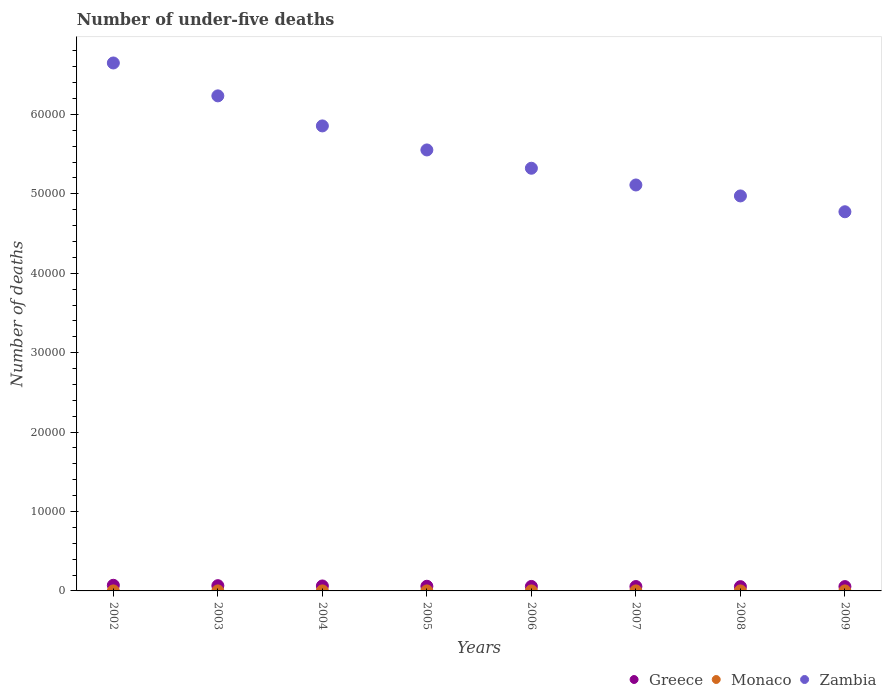How many different coloured dotlines are there?
Your answer should be very brief. 3. What is the number of under-five deaths in Greece in 2007?
Make the answer very short. 552. Across all years, what is the maximum number of under-five deaths in Zambia?
Your answer should be very brief. 6.65e+04. Across all years, what is the minimum number of under-five deaths in Zambia?
Provide a succinct answer. 4.77e+04. In which year was the number of under-five deaths in Monaco maximum?
Your response must be concise. 2003. What is the total number of under-five deaths in Zambia in the graph?
Your answer should be compact. 4.45e+05. What is the difference between the number of under-five deaths in Greece in 2003 and that in 2007?
Your answer should be very brief. 109. What is the difference between the number of under-five deaths in Monaco in 2006 and the number of under-five deaths in Zambia in 2005?
Provide a short and direct response. -5.55e+04. What is the average number of under-five deaths in Greece per year?
Your answer should be very brief. 597.75. In the year 2005, what is the difference between the number of under-five deaths in Zambia and number of under-five deaths in Monaco?
Provide a succinct answer. 5.55e+04. In how many years, is the number of under-five deaths in Monaco greater than 36000?
Provide a succinct answer. 0. What is the ratio of the number of under-five deaths in Zambia in 2006 to that in 2008?
Your answer should be compact. 1.07. Is the number of under-five deaths in Zambia in 2004 less than that in 2009?
Ensure brevity in your answer.  No. Is it the case that in every year, the sum of the number of under-five deaths in Monaco and number of under-five deaths in Zambia  is greater than the number of under-five deaths in Greece?
Offer a terse response. Yes. Does the number of under-five deaths in Monaco monotonically increase over the years?
Your answer should be very brief. No. Is the number of under-five deaths in Zambia strictly greater than the number of under-five deaths in Greece over the years?
Ensure brevity in your answer.  Yes. Is the number of under-five deaths in Monaco strictly less than the number of under-five deaths in Zambia over the years?
Make the answer very short. Yes. How many years are there in the graph?
Your answer should be very brief. 8. Are the values on the major ticks of Y-axis written in scientific E-notation?
Ensure brevity in your answer.  No. Does the graph contain any zero values?
Offer a very short reply. No. How many legend labels are there?
Ensure brevity in your answer.  3. How are the legend labels stacked?
Make the answer very short. Horizontal. What is the title of the graph?
Keep it short and to the point. Number of under-five deaths. Does "Brunei Darussalam" appear as one of the legend labels in the graph?
Offer a very short reply. No. What is the label or title of the X-axis?
Your answer should be very brief. Years. What is the label or title of the Y-axis?
Give a very brief answer. Number of deaths. What is the Number of deaths in Greece in 2002?
Your response must be concise. 710. What is the Number of deaths of Zambia in 2002?
Keep it short and to the point. 6.65e+04. What is the Number of deaths of Greece in 2003?
Your response must be concise. 661. What is the Number of deaths of Zambia in 2003?
Offer a very short reply. 6.23e+04. What is the Number of deaths of Greece in 2004?
Your response must be concise. 624. What is the Number of deaths in Zambia in 2004?
Your answer should be compact. 5.86e+04. What is the Number of deaths of Greece in 2005?
Ensure brevity in your answer.  588. What is the Number of deaths of Zambia in 2005?
Provide a short and direct response. 5.55e+04. What is the Number of deaths of Greece in 2006?
Give a very brief answer. 564. What is the Number of deaths in Monaco in 2006?
Your answer should be compact. 1. What is the Number of deaths in Zambia in 2006?
Provide a succinct answer. 5.32e+04. What is the Number of deaths in Greece in 2007?
Your answer should be very brief. 552. What is the Number of deaths in Zambia in 2007?
Your answer should be very brief. 5.11e+04. What is the Number of deaths of Greece in 2008?
Your answer should be very brief. 538. What is the Number of deaths of Monaco in 2008?
Offer a very short reply. 1. What is the Number of deaths of Zambia in 2008?
Give a very brief answer. 4.97e+04. What is the Number of deaths in Greece in 2009?
Your answer should be very brief. 545. What is the Number of deaths of Monaco in 2009?
Provide a short and direct response. 1. What is the Number of deaths in Zambia in 2009?
Keep it short and to the point. 4.77e+04. Across all years, what is the maximum Number of deaths of Greece?
Offer a terse response. 710. Across all years, what is the maximum Number of deaths of Zambia?
Give a very brief answer. 6.65e+04. Across all years, what is the minimum Number of deaths in Greece?
Offer a terse response. 538. Across all years, what is the minimum Number of deaths in Zambia?
Ensure brevity in your answer.  4.77e+04. What is the total Number of deaths in Greece in the graph?
Provide a succinct answer. 4782. What is the total Number of deaths of Zambia in the graph?
Your answer should be compact. 4.45e+05. What is the difference between the Number of deaths of Greece in 2002 and that in 2003?
Make the answer very short. 49. What is the difference between the Number of deaths of Monaco in 2002 and that in 2003?
Your response must be concise. -1. What is the difference between the Number of deaths in Zambia in 2002 and that in 2003?
Offer a terse response. 4142. What is the difference between the Number of deaths of Monaco in 2002 and that in 2004?
Keep it short and to the point. -1. What is the difference between the Number of deaths of Zambia in 2002 and that in 2004?
Your answer should be compact. 7925. What is the difference between the Number of deaths in Greece in 2002 and that in 2005?
Your answer should be very brief. 122. What is the difference between the Number of deaths of Monaco in 2002 and that in 2005?
Provide a succinct answer. 0. What is the difference between the Number of deaths of Zambia in 2002 and that in 2005?
Your answer should be compact. 1.10e+04. What is the difference between the Number of deaths in Greece in 2002 and that in 2006?
Your response must be concise. 146. What is the difference between the Number of deaths of Monaco in 2002 and that in 2006?
Offer a very short reply. 0. What is the difference between the Number of deaths in Zambia in 2002 and that in 2006?
Your response must be concise. 1.33e+04. What is the difference between the Number of deaths of Greece in 2002 and that in 2007?
Give a very brief answer. 158. What is the difference between the Number of deaths in Monaco in 2002 and that in 2007?
Your answer should be compact. 0. What is the difference between the Number of deaths of Zambia in 2002 and that in 2007?
Offer a very short reply. 1.54e+04. What is the difference between the Number of deaths of Greece in 2002 and that in 2008?
Keep it short and to the point. 172. What is the difference between the Number of deaths in Zambia in 2002 and that in 2008?
Your response must be concise. 1.67e+04. What is the difference between the Number of deaths in Greece in 2002 and that in 2009?
Ensure brevity in your answer.  165. What is the difference between the Number of deaths in Monaco in 2002 and that in 2009?
Your answer should be compact. 0. What is the difference between the Number of deaths of Zambia in 2002 and that in 2009?
Give a very brief answer. 1.87e+04. What is the difference between the Number of deaths in Monaco in 2003 and that in 2004?
Make the answer very short. 0. What is the difference between the Number of deaths of Zambia in 2003 and that in 2004?
Give a very brief answer. 3783. What is the difference between the Number of deaths of Monaco in 2003 and that in 2005?
Your answer should be compact. 1. What is the difference between the Number of deaths of Zambia in 2003 and that in 2005?
Offer a terse response. 6810. What is the difference between the Number of deaths of Greece in 2003 and that in 2006?
Give a very brief answer. 97. What is the difference between the Number of deaths of Zambia in 2003 and that in 2006?
Ensure brevity in your answer.  9113. What is the difference between the Number of deaths of Greece in 2003 and that in 2007?
Provide a short and direct response. 109. What is the difference between the Number of deaths in Zambia in 2003 and that in 2007?
Make the answer very short. 1.12e+04. What is the difference between the Number of deaths in Greece in 2003 and that in 2008?
Make the answer very short. 123. What is the difference between the Number of deaths of Zambia in 2003 and that in 2008?
Keep it short and to the point. 1.26e+04. What is the difference between the Number of deaths in Greece in 2003 and that in 2009?
Your response must be concise. 116. What is the difference between the Number of deaths of Monaco in 2003 and that in 2009?
Your response must be concise. 1. What is the difference between the Number of deaths of Zambia in 2003 and that in 2009?
Offer a very short reply. 1.46e+04. What is the difference between the Number of deaths of Zambia in 2004 and that in 2005?
Keep it short and to the point. 3027. What is the difference between the Number of deaths in Monaco in 2004 and that in 2006?
Provide a succinct answer. 1. What is the difference between the Number of deaths of Zambia in 2004 and that in 2006?
Offer a very short reply. 5330. What is the difference between the Number of deaths in Greece in 2004 and that in 2007?
Keep it short and to the point. 72. What is the difference between the Number of deaths of Zambia in 2004 and that in 2007?
Provide a short and direct response. 7438. What is the difference between the Number of deaths in Greece in 2004 and that in 2008?
Give a very brief answer. 86. What is the difference between the Number of deaths of Zambia in 2004 and that in 2008?
Offer a very short reply. 8816. What is the difference between the Number of deaths of Greece in 2004 and that in 2009?
Your answer should be very brief. 79. What is the difference between the Number of deaths in Zambia in 2004 and that in 2009?
Your answer should be very brief. 1.08e+04. What is the difference between the Number of deaths of Zambia in 2005 and that in 2006?
Provide a succinct answer. 2303. What is the difference between the Number of deaths of Greece in 2005 and that in 2007?
Your response must be concise. 36. What is the difference between the Number of deaths of Zambia in 2005 and that in 2007?
Your answer should be very brief. 4411. What is the difference between the Number of deaths in Zambia in 2005 and that in 2008?
Ensure brevity in your answer.  5789. What is the difference between the Number of deaths of Monaco in 2005 and that in 2009?
Give a very brief answer. 0. What is the difference between the Number of deaths of Zambia in 2005 and that in 2009?
Keep it short and to the point. 7783. What is the difference between the Number of deaths in Zambia in 2006 and that in 2007?
Your answer should be compact. 2108. What is the difference between the Number of deaths of Greece in 2006 and that in 2008?
Keep it short and to the point. 26. What is the difference between the Number of deaths of Monaco in 2006 and that in 2008?
Ensure brevity in your answer.  0. What is the difference between the Number of deaths of Zambia in 2006 and that in 2008?
Offer a very short reply. 3486. What is the difference between the Number of deaths of Monaco in 2006 and that in 2009?
Offer a terse response. 0. What is the difference between the Number of deaths in Zambia in 2006 and that in 2009?
Offer a very short reply. 5480. What is the difference between the Number of deaths in Greece in 2007 and that in 2008?
Provide a short and direct response. 14. What is the difference between the Number of deaths of Monaco in 2007 and that in 2008?
Your answer should be very brief. 0. What is the difference between the Number of deaths in Zambia in 2007 and that in 2008?
Make the answer very short. 1378. What is the difference between the Number of deaths of Greece in 2007 and that in 2009?
Provide a succinct answer. 7. What is the difference between the Number of deaths in Monaco in 2007 and that in 2009?
Make the answer very short. 0. What is the difference between the Number of deaths in Zambia in 2007 and that in 2009?
Give a very brief answer. 3372. What is the difference between the Number of deaths in Zambia in 2008 and that in 2009?
Your answer should be very brief. 1994. What is the difference between the Number of deaths in Greece in 2002 and the Number of deaths in Monaco in 2003?
Your answer should be very brief. 708. What is the difference between the Number of deaths in Greece in 2002 and the Number of deaths in Zambia in 2003?
Keep it short and to the point. -6.16e+04. What is the difference between the Number of deaths in Monaco in 2002 and the Number of deaths in Zambia in 2003?
Make the answer very short. -6.23e+04. What is the difference between the Number of deaths in Greece in 2002 and the Number of deaths in Monaco in 2004?
Ensure brevity in your answer.  708. What is the difference between the Number of deaths of Greece in 2002 and the Number of deaths of Zambia in 2004?
Provide a succinct answer. -5.78e+04. What is the difference between the Number of deaths in Monaco in 2002 and the Number of deaths in Zambia in 2004?
Ensure brevity in your answer.  -5.86e+04. What is the difference between the Number of deaths in Greece in 2002 and the Number of deaths in Monaco in 2005?
Offer a very short reply. 709. What is the difference between the Number of deaths of Greece in 2002 and the Number of deaths of Zambia in 2005?
Offer a very short reply. -5.48e+04. What is the difference between the Number of deaths of Monaco in 2002 and the Number of deaths of Zambia in 2005?
Make the answer very short. -5.55e+04. What is the difference between the Number of deaths of Greece in 2002 and the Number of deaths of Monaco in 2006?
Your response must be concise. 709. What is the difference between the Number of deaths of Greece in 2002 and the Number of deaths of Zambia in 2006?
Ensure brevity in your answer.  -5.25e+04. What is the difference between the Number of deaths of Monaco in 2002 and the Number of deaths of Zambia in 2006?
Give a very brief answer. -5.32e+04. What is the difference between the Number of deaths of Greece in 2002 and the Number of deaths of Monaco in 2007?
Ensure brevity in your answer.  709. What is the difference between the Number of deaths of Greece in 2002 and the Number of deaths of Zambia in 2007?
Make the answer very short. -5.04e+04. What is the difference between the Number of deaths of Monaco in 2002 and the Number of deaths of Zambia in 2007?
Offer a terse response. -5.11e+04. What is the difference between the Number of deaths of Greece in 2002 and the Number of deaths of Monaco in 2008?
Your answer should be compact. 709. What is the difference between the Number of deaths of Greece in 2002 and the Number of deaths of Zambia in 2008?
Give a very brief answer. -4.90e+04. What is the difference between the Number of deaths of Monaco in 2002 and the Number of deaths of Zambia in 2008?
Your answer should be compact. -4.97e+04. What is the difference between the Number of deaths of Greece in 2002 and the Number of deaths of Monaco in 2009?
Your answer should be compact. 709. What is the difference between the Number of deaths of Greece in 2002 and the Number of deaths of Zambia in 2009?
Make the answer very short. -4.70e+04. What is the difference between the Number of deaths in Monaco in 2002 and the Number of deaths in Zambia in 2009?
Ensure brevity in your answer.  -4.77e+04. What is the difference between the Number of deaths of Greece in 2003 and the Number of deaths of Monaco in 2004?
Offer a terse response. 659. What is the difference between the Number of deaths of Greece in 2003 and the Number of deaths of Zambia in 2004?
Keep it short and to the point. -5.79e+04. What is the difference between the Number of deaths in Monaco in 2003 and the Number of deaths in Zambia in 2004?
Give a very brief answer. -5.86e+04. What is the difference between the Number of deaths in Greece in 2003 and the Number of deaths in Monaco in 2005?
Make the answer very short. 660. What is the difference between the Number of deaths in Greece in 2003 and the Number of deaths in Zambia in 2005?
Make the answer very short. -5.49e+04. What is the difference between the Number of deaths in Monaco in 2003 and the Number of deaths in Zambia in 2005?
Your answer should be very brief. -5.55e+04. What is the difference between the Number of deaths of Greece in 2003 and the Number of deaths of Monaco in 2006?
Your answer should be compact. 660. What is the difference between the Number of deaths in Greece in 2003 and the Number of deaths in Zambia in 2006?
Make the answer very short. -5.26e+04. What is the difference between the Number of deaths in Monaco in 2003 and the Number of deaths in Zambia in 2006?
Your answer should be very brief. -5.32e+04. What is the difference between the Number of deaths in Greece in 2003 and the Number of deaths in Monaco in 2007?
Make the answer very short. 660. What is the difference between the Number of deaths in Greece in 2003 and the Number of deaths in Zambia in 2007?
Keep it short and to the point. -5.05e+04. What is the difference between the Number of deaths in Monaco in 2003 and the Number of deaths in Zambia in 2007?
Make the answer very short. -5.11e+04. What is the difference between the Number of deaths of Greece in 2003 and the Number of deaths of Monaco in 2008?
Your answer should be compact. 660. What is the difference between the Number of deaths of Greece in 2003 and the Number of deaths of Zambia in 2008?
Your response must be concise. -4.91e+04. What is the difference between the Number of deaths in Monaco in 2003 and the Number of deaths in Zambia in 2008?
Keep it short and to the point. -4.97e+04. What is the difference between the Number of deaths in Greece in 2003 and the Number of deaths in Monaco in 2009?
Your response must be concise. 660. What is the difference between the Number of deaths in Greece in 2003 and the Number of deaths in Zambia in 2009?
Your response must be concise. -4.71e+04. What is the difference between the Number of deaths in Monaco in 2003 and the Number of deaths in Zambia in 2009?
Your response must be concise. -4.77e+04. What is the difference between the Number of deaths in Greece in 2004 and the Number of deaths in Monaco in 2005?
Offer a terse response. 623. What is the difference between the Number of deaths in Greece in 2004 and the Number of deaths in Zambia in 2005?
Your response must be concise. -5.49e+04. What is the difference between the Number of deaths of Monaco in 2004 and the Number of deaths of Zambia in 2005?
Provide a short and direct response. -5.55e+04. What is the difference between the Number of deaths in Greece in 2004 and the Number of deaths in Monaco in 2006?
Provide a succinct answer. 623. What is the difference between the Number of deaths of Greece in 2004 and the Number of deaths of Zambia in 2006?
Give a very brief answer. -5.26e+04. What is the difference between the Number of deaths in Monaco in 2004 and the Number of deaths in Zambia in 2006?
Keep it short and to the point. -5.32e+04. What is the difference between the Number of deaths in Greece in 2004 and the Number of deaths in Monaco in 2007?
Give a very brief answer. 623. What is the difference between the Number of deaths in Greece in 2004 and the Number of deaths in Zambia in 2007?
Offer a very short reply. -5.05e+04. What is the difference between the Number of deaths of Monaco in 2004 and the Number of deaths of Zambia in 2007?
Offer a very short reply. -5.11e+04. What is the difference between the Number of deaths of Greece in 2004 and the Number of deaths of Monaco in 2008?
Keep it short and to the point. 623. What is the difference between the Number of deaths of Greece in 2004 and the Number of deaths of Zambia in 2008?
Ensure brevity in your answer.  -4.91e+04. What is the difference between the Number of deaths in Monaco in 2004 and the Number of deaths in Zambia in 2008?
Provide a succinct answer. -4.97e+04. What is the difference between the Number of deaths of Greece in 2004 and the Number of deaths of Monaco in 2009?
Offer a very short reply. 623. What is the difference between the Number of deaths in Greece in 2004 and the Number of deaths in Zambia in 2009?
Your answer should be very brief. -4.71e+04. What is the difference between the Number of deaths in Monaco in 2004 and the Number of deaths in Zambia in 2009?
Give a very brief answer. -4.77e+04. What is the difference between the Number of deaths of Greece in 2005 and the Number of deaths of Monaco in 2006?
Keep it short and to the point. 587. What is the difference between the Number of deaths of Greece in 2005 and the Number of deaths of Zambia in 2006?
Your answer should be compact. -5.26e+04. What is the difference between the Number of deaths in Monaco in 2005 and the Number of deaths in Zambia in 2006?
Ensure brevity in your answer.  -5.32e+04. What is the difference between the Number of deaths of Greece in 2005 and the Number of deaths of Monaco in 2007?
Your answer should be very brief. 587. What is the difference between the Number of deaths of Greece in 2005 and the Number of deaths of Zambia in 2007?
Your answer should be compact. -5.05e+04. What is the difference between the Number of deaths of Monaco in 2005 and the Number of deaths of Zambia in 2007?
Offer a terse response. -5.11e+04. What is the difference between the Number of deaths of Greece in 2005 and the Number of deaths of Monaco in 2008?
Provide a succinct answer. 587. What is the difference between the Number of deaths in Greece in 2005 and the Number of deaths in Zambia in 2008?
Your answer should be very brief. -4.91e+04. What is the difference between the Number of deaths in Monaco in 2005 and the Number of deaths in Zambia in 2008?
Keep it short and to the point. -4.97e+04. What is the difference between the Number of deaths in Greece in 2005 and the Number of deaths in Monaco in 2009?
Ensure brevity in your answer.  587. What is the difference between the Number of deaths in Greece in 2005 and the Number of deaths in Zambia in 2009?
Your answer should be compact. -4.72e+04. What is the difference between the Number of deaths of Monaco in 2005 and the Number of deaths of Zambia in 2009?
Your answer should be compact. -4.77e+04. What is the difference between the Number of deaths in Greece in 2006 and the Number of deaths in Monaco in 2007?
Provide a succinct answer. 563. What is the difference between the Number of deaths of Greece in 2006 and the Number of deaths of Zambia in 2007?
Keep it short and to the point. -5.06e+04. What is the difference between the Number of deaths of Monaco in 2006 and the Number of deaths of Zambia in 2007?
Ensure brevity in your answer.  -5.11e+04. What is the difference between the Number of deaths of Greece in 2006 and the Number of deaths of Monaco in 2008?
Offer a very short reply. 563. What is the difference between the Number of deaths of Greece in 2006 and the Number of deaths of Zambia in 2008?
Give a very brief answer. -4.92e+04. What is the difference between the Number of deaths of Monaco in 2006 and the Number of deaths of Zambia in 2008?
Your answer should be very brief. -4.97e+04. What is the difference between the Number of deaths of Greece in 2006 and the Number of deaths of Monaco in 2009?
Offer a very short reply. 563. What is the difference between the Number of deaths in Greece in 2006 and the Number of deaths in Zambia in 2009?
Keep it short and to the point. -4.72e+04. What is the difference between the Number of deaths of Monaco in 2006 and the Number of deaths of Zambia in 2009?
Make the answer very short. -4.77e+04. What is the difference between the Number of deaths in Greece in 2007 and the Number of deaths in Monaco in 2008?
Make the answer very short. 551. What is the difference between the Number of deaths in Greece in 2007 and the Number of deaths in Zambia in 2008?
Give a very brief answer. -4.92e+04. What is the difference between the Number of deaths of Monaco in 2007 and the Number of deaths of Zambia in 2008?
Make the answer very short. -4.97e+04. What is the difference between the Number of deaths in Greece in 2007 and the Number of deaths in Monaco in 2009?
Give a very brief answer. 551. What is the difference between the Number of deaths of Greece in 2007 and the Number of deaths of Zambia in 2009?
Provide a short and direct response. -4.72e+04. What is the difference between the Number of deaths in Monaco in 2007 and the Number of deaths in Zambia in 2009?
Give a very brief answer. -4.77e+04. What is the difference between the Number of deaths of Greece in 2008 and the Number of deaths of Monaco in 2009?
Offer a very short reply. 537. What is the difference between the Number of deaths in Greece in 2008 and the Number of deaths in Zambia in 2009?
Provide a succinct answer. -4.72e+04. What is the difference between the Number of deaths of Monaco in 2008 and the Number of deaths of Zambia in 2009?
Keep it short and to the point. -4.77e+04. What is the average Number of deaths in Greece per year?
Your answer should be very brief. 597.75. What is the average Number of deaths in Zambia per year?
Keep it short and to the point. 5.56e+04. In the year 2002, what is the difference between the Number of deaths of Greece and Number of deaths of Monaco?
Your answer should be very brief. 709. In the year 2002, what is the difference between the Number of deaths in Greece and Number of deaths in Zambia?
Offer a terse response. -6.58e+04. In the year 2002, what is the difference between the Number of deaths of Monaco and Number of deaths of Zambia?
Offer a terse response. -6.65e+04. In the year 2003, what is the difference between the Number of deaths of Greece and Number of deaths of Monaco?
Provide a short and direct response. 659. In the year 2003, what is the difference between the Number of deaths in Greece and Number of deaths in Zambia?
Provide a succinct answer. -6.17e+04. In the year 2003, what is the difference between the Number of deaths in Monaco and Number of deaths in Zambia?
Your answer should be very brief. -6.23e+04. In the year 2004, what is the difference between the Number of deaths in Greece and Number of deaths in Monaco?
Your answer should be very brief. 622. In the year 2004, what is the difference between the Number of deaths of Greece and Number of deaths of Zambia?
Your response must be concise. -5.79e+04. In the year 2004, what is the difference between the Number of deaths of Monaco and Number of deaths of Zambia?
Your answer should be very brief. -5.86e+04. In the year 2005, what is the difference between the Number of deaths in Greece and Number of deaths in Monaco?
Provide a succinct answer. 587. In the year 2005, what is the difference between the Number of deaths of Greece and Number of deaths of Zambia?
Your answer should be compact. -5.49e+04. In the year 2005, what is the difference between the Number of deaths in Monaco and Number of deaths in Zambia?
Your answer should be compact. -5.55e+04. In the year 2006, what is the difference between the Number of deaths of Greece and Number of deaths of Monaco?
Provide a short and direct response. 563. In the year 2006, what is the difference between the Number of deaths of Greece and Number of deaths of Zambia?
Provide a short and direct response. -5.27e+04. In the year 2006, what is the difference between the Number of deaths of Monaco and Number of deaths of Zambia?
Your response must be concise. -5.32e+04. In the year 2007, what is the difference between the Number of deaths of Greece and Number of deaths of Monaco?
Your answer should be compact. 551. In the year 2007, what is the difference between the Number of deaths of Greece and Number of deaths of Zambia?
Make the answer very short. -5.06e+04. In the year 2007, what is the difference between the Number of deaths in Monaco and Number of deaths in Zambia?
Provide a short and direct response. -5.11e+04. In the year 2008, what is the difference between the Number of deaths in Greece and Number of deaths in Monaco?
Give a very brief answer. 537. In the year 2008, what is the difference between the Number of deaths of Greece and Number of deaths of Zambia?
Your answer should be compact. -4.92e+04. In the year 2008, what is the difference between the Number of deaths of Monaco and Number of deaths of Zambia?
Make the answer very short. -4.97e+04. In the year 2009, what is the difference between the Number of deaths in Greece and Number of deaths in Monaco?
Your answer should be very brief. 544. In the year 2009, what is the difference between the Number of deaths of Greece and Number of deaths of Zambia?
Keep it short and to the point. -4.72e+04. In the year 2009, what is the difference between the Number of deaths of Monaco and Number of deaths of Zambia?
Keep it short and to the point. -4.77e+04. What is the ratio of the Number of deaths in Greece in 2002 to that in 2003?
Your response must be concise. 1.07. What is the ratio of the Number of deaths of Monaco in 2002 to that in 2003?
Ensure brevity in your answer.  0.5. What is the ratio of the Number of deaths of Zambia in 2002 to that in 2003?
Your answer should be very brief. 1.07. What is the ratio of the Number of deaths in Greece in 2002 to that in 2004?
Your answer should be compact. 1.14. What is the ratio of the Number of deaths in Zambia in 2002 to that in 2004?
Your response must be concise. 1.14. What is the ratio of the Number of deaths in Greece in 2002 to that in 2005?
Give a very brief answer. 1.21. What is the ratio of the Number of deaths in Zambia in 2002 to that in 2005?
Offer a terse response. 1.2. What is the ratio of the Number of deaths in Greece in 2002 to that in 2006?
Your answer should be compact. 1.26. What is the ratio of the Number of deaths of Zambia in 2002 to that in 2006?
Provide a short and direct response. 1.25. What is the ratio of the Number of deaths in Greece in 2002 to that in 2007?
Your response must be concise. 1.29. What is the ratio of the Number of deaths in Monaco in 2002 to that in 2007?
Offer a very short reply. 1. What is the ratio of the Number of deaths of Zambia in 2002 to that in 2007?
Keep it short and to the point. 1.3. What is the ratio of the Number of deaths of Greece in 2002 to that in 2008?
Your answer should be compact. 1.32. What is the ratio of the Number of deaths in Monaco in 2002 to that in 2008?
Your answer should be compact. 1. What is the ratio of the Number of deaths of Zambia in 2002 to that in 2008?
Provide a succinct answer. 1.34. What is the ratio of the Number of deaths of Greece in 2002 to that in 2009?
Ensure brevity in your answer.  1.3. What is the ratio of the Number of deaths of Zambia in 2002 to that in 2009?
Provide a succinct answer. 1.39. What is the ratio of the Number of deaths in Greece in 2003 to that in 2004?
Make the answer very short. 1.06. What is the ratio of the Number of deaths of Monaco in 2003 to that in 2004?
Ensure brevity in your answer.  1. What is the ratio of the Number of deaths in Zambia in 2003 to that in 2004?
Ensure brevity in your answer.  1.06. What is the ratio of the Number of deaths of Greece in 2003 to that in 2005?
Your response must be concise. 1.12. What is the ratio of the Number of deaths in Zambia in 2003 to that in 2005?
Make the answer very short. 1.12. What is the ratio of the Number of deaths in Greece in 2003 to that in 2006?
Ensure brevity in your answer.  1.17. What is the ratio of the Number of deaths in Monaco in 2003 to that in 2006?
Provide a short and direct response. 2. What is the ratio of the Number of deaths of Zambia in 2003 to that in 2006?
Give a very brief answer. 1.17. What is the ratio of the Number of deaths of Greece in 2003 to that in 2007?
Keep it short and to the point. 1.2. What is the ratio of the Number of deaths of Monaco in 2003 to that in 2007?
Offer a very short reply. 2. What is the ratio of the Number of deaths in Zambia in 2003 to that in 2007?
Keep it short and to the point. 1.22. What is the ratio of the Number of deaths of Greece in 2003 to that in 2008?
Give a very brief answer. 1.23. What is the ratio of the Number of deaths in Monaco in 2003 to that in 2008?
Give a very brief answer. 2. What is the ratio of the Number of deaths in Zambia in 2003 to that in 2008?
Your answer should be compact. 1.25. What is the ratio of the Number of deaths in Greece in 2003 to that in 2009?
Your answer should be compact. 1.21. What is the ratio of the Number of deaths in Zambia in 2003 to that in 2009?
Your answer should be compact. 1.31. What is the ratio of the Number of deaths in Greece in 2004 to that in 2005?
Your response must be concise. 1.06. What is the ratio of the Number of deaths of Zambia in 2004 to that in 2005?
Provide a short and direct response. 1.05. What is the ratio of the Number of deaths of Greece in 2004 to that in 2006?
Ensure brevity in your answer.  1.11. What is the ratio of the Number of deaths of Monaco in 2004 to that in 2006?
Provide a succinct answer. 2. What is the ratio of the Number of deaths of Zambia in 2004 to that in 2006?
Provide a succinct answer. 1.1. What is the ratio of the Number of deaths in Greece in 2004 to that in 2007?
Give a very brief answer. 1.13. What is the ratio of the Number of deaths in Monaco in 2004 to that in 2007?
Make the answer very short. 2. What is the ratio of the Number of deaths of Zambia in 2004 to that in 2007?
Offer a very short reply. 1.15. What is the ratio of the Number of deaths in Greece in 2004 to that in 2008?
Provide a short and direct response. 1.16. What is the ratio of the Number of deaths in Monaco in 2004 to that in 2008?
Provide a succinct answer. 2. What is the ratio of the Number of deaths in Zambia in 2004 to that in 2008?
Offer a very short reply. 1.18. What is the ratio of the Number of deaths of Greece in 2004 to that in 2009?
Your answer should be compact. 1.15. What is the ratio of the Number of deaths in Zambia in 2004 to that in 2009?
Your response must be concise. 1.23. What is the ratio of the Number of deaths of Greece in 2005 to that in 2006?
Offer a very short reply. 1.04. What is the ratio of the Number of deaths in Monaco in 2005 to that in 2006?
Give a very brief answer. 1. What is the ratio of the Number of deaths of Zambia in 2005 to that in 2006?
Give a very brief answer. 1.04. What is the ratio of the Number of deaths in Greece in 2005 to that in 2007?
Your answer should be very brief. 1.07. What is the ratio of the Number of deaths in Monaco in 2005 to that in 2007?
Give a very brief answer. 1. What is the ratio of the Number of deaths in Zambia in 2005 to that in 2007?
Offer a very short reply. 1.09. What is the ratio of the Number of deaths of Greece in 2005 to that in 2008?
Offer a very short reply. 1.09. What is the ratio of the Number of deaths in Monaco in 2005 to that in 2008?
Keep it short and to the point. 1. What is the ratio of the Number of deaths in Zambia in 2005 to that in 2008?
Offer a terse response. 1.12. What is the ratio of the Number of deaths of Greece in 2005 to that in 2009?
Offer a terse response. 1.08. What is the ratio of the Number of deaths of Zambia in 2005 to that in 2009?
Keep it short and to the point. 1.16. What is the ratio of the Number of deaths of Greece in 2006 to that in 2007?
Give a very brief answer. 1.02. What is the ratio of the Number of deaths in Zambia in 2006 to that in 2007?
Your answer should be compact. 1.04. What is the ratio of the Number of deaths of Greece in 2006 to that in 2008?
Your answer should be very brief. 1.05. What is the ratio of the Number of deaths of Zambia in 2006 to that in 2008?
Your answer should be compact. 1.07. What is the ratio of the Number of deaths of Greece in 2006 to that in 2009?
Your answer should be very brief. 1.03. What is the ratio of the Number of deaths in Zambia in 2006 to that in 2009?
Your response must be concise. 1.11. What is the ratio of the Number of deaths in Monaco in 2007 to that in 2008?
Make the answer very short. 1. What is the ratio of the Number of deaths of Zambia in 2007 to that in 2008?
Provide a succinct answer. 1.03. What is the ratio of the Number of deaths of Greece in 2007 to that in 2009?
Your response must be concise. 1.01. What is the ratio of the Number of deaths in Monaco in 2007 to that in 2009?
Provide a short and direct response. 1. What is the ratio of the Number of deaths in Zambia in 2007 to that in 2009?
Offer a very short reply. 1.07. What is the ratio of the Number of deaths of Greece in 2008 to that in 2009?
Offer a terse response. 0.99. What is the ratio of the Number of deaths of Zambia in 2008 to that in 2009?
Your answer should be very brief. 1.04. What is the difference between the highest and the second highest Number of deaths of Monaco?
Give a very brief answer. 0. What is the difference between the highest and the second highest Number of deaths of Zambia?
Your answer should be very brief. 4142. What is the difference between the highest and the lowest Number of deaths in Greece?
Offer a very short reply. 172. What is the difference between the highest and the lowest Number of deaths in Zambia?
Ensure brevity in your answer.  1.87e+04. 